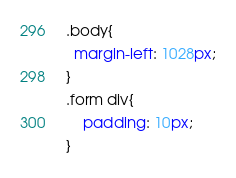Convert code to text. <code><loc_0><loc_0><loc_500><loc_500><_CSS_>.body{
  margin-left: 1028px;
}
.form div{
    padding: 10px;
}</code> 